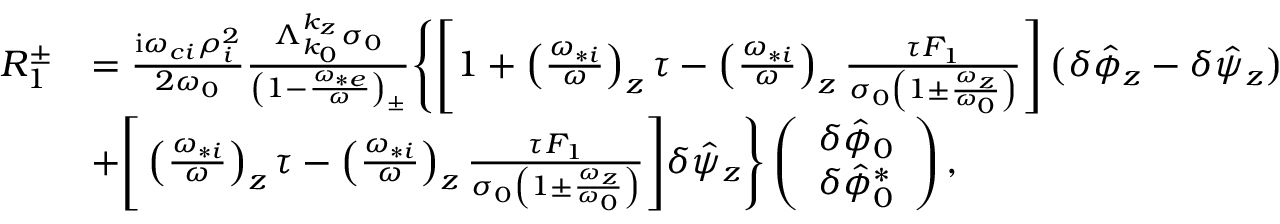<formula> <loc_0><loc_0><loc_500><loc_500>\begin{array} { r l } { R _ { 1 } ^ { \pm } } & { = \frac { i \omega _ { c i } \rho _ { i } ^ { 2 } } { 2 \omega _ { 0 } } \frac { \Lambda _ { k _ { 0 } } ^ { k _ { z } } \sigma _ { 0 } } { \left ( 1 - \frac { \omega _ { * e } } { \omega } \right ) _ { \pm } } \left \{ \left [ 1 + \left ( \frac { \omega _ { * i } } { \omega } \right ) _ { z } \tau - \left ( \frac { \omega _ { * i } } { \omega } \right ) _ { z } \frac { \tau F _ { 1 } } { \sigma _ { 0 } \left ( 1 \pm \frac { \omega _ { z } } { \omega _ { 0 } } \right ) } \right ] \left ( \delta \hat { \phi } _ { z } - \delta \hat { \psi } _ { z } \right ) } \\ & { + \left [ \left ( \frac { \omega _ { * i } } { \omega } \right ) _ { z } \tau - \left ( \frac { \omega _ { * i } } { \omega } \right ) _ { z } \frac { \tau F _ { 1 } } { \sigma _ { 0 } \left ( 1 \pm \frac { \omega _ { z } } { \omega _ { 0 } } \right ) } \right ] \delta \hat { \psi } _ { z } \right \} \left ( \begin{array} { c } { \delta \hat { \phi } _ { 0 } } \\ { \delta \hat { \phi } _ { 0 } ^ { * } } \end{array} \right ) , } \end{array}</formula> 